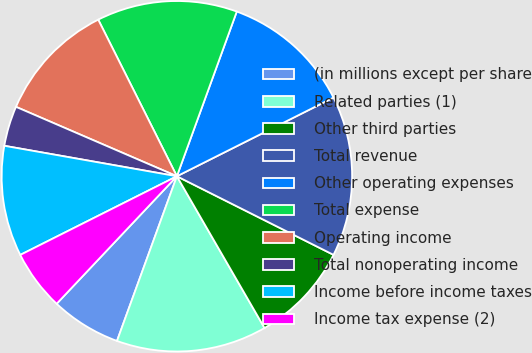Convert chart. <chart><loc_0><loc_0><loc_500><loc_500><pie_chart><fcel>(in millions except per share<fcel>Related parties (1)<fcel>Other third parties<fcel>Total revenue<fcel>Other operating expenses<fcel>Total expense<fcel>Operating income<fcel>Total nonoperating income<fcel>Income before income taxes<fcel>Income tax expense (2)<nl><fcel>6.48%<fcel>13.89%<fcel>9.26%<fcel>14.81%<fcel>12.04%<fcel>12.96%<fcel>11.11%<fcel>3.7%<fcel>10.19%<fcel>5.56%<nl></chart> 